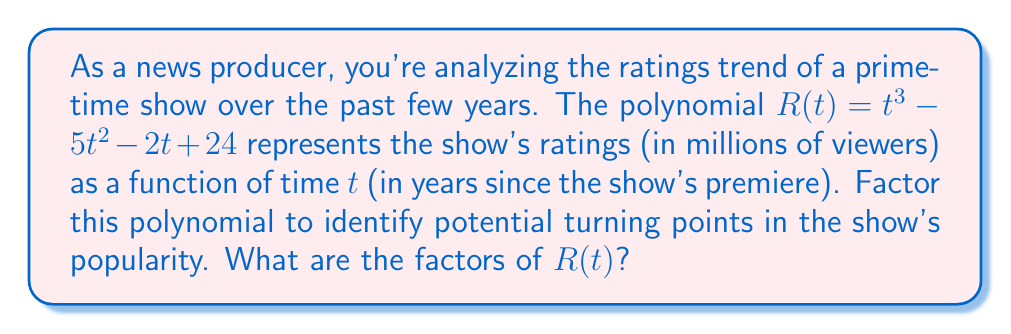Provide a solution to this math problem. Let's approach this step-by-step:

1) First, we'll check if there are any rational roots using the rational root theorem. The possible rational roots are the factors of the constant term: ±1, ±2, ±3, ±4, ±6, ±8, ±12, ±24.

2) Testing these values, we find that $R(4) = 0$. So $(t-4)$ is a factor.

3) We can use polynomial long division to divide $R(t)$ by $(t-4)$:

   $$\frac{t^3 - 5t^2 - 2t + 24}{t - 4} = t^2 - t - 6$$

4) Now we have: $R(t) = (t-4)(t^2 - t - 6)$

5) The quadratic factor $t^2 - t - 6$ can be factored further:
   
   $t^2 - t - 6 = (t-3)(t+2)$

6) Therefore, the complete factorization is:

   $R(t) = (t-4)(t-3)(t+2)$

This factorization reveals that the ratings function has three roots: at $t=4$, $t=3$, and $t=-2$. As a news producer, you might interpret these as potential significant points in the show's history, possibly corresponding to major changes in content, cast, or time slot.
Answer: $(t-4)(t-3)(t+2)$ 